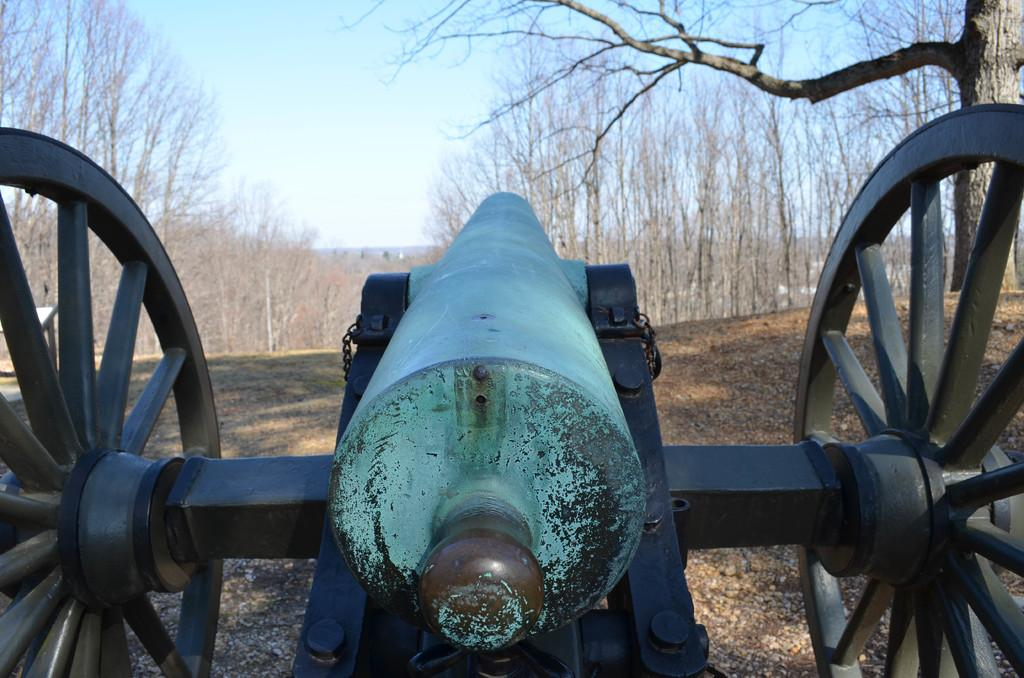What is the main object in the foreground of the image? There is a cannon in the foreground of the image. What type of vegetation can be seen on the right side of the image? There is a tree on the right side of the image. What is visible in the background of the image? The background of the image is the sky. What is the condition of the jail in the image? There is no jail present in the image. 